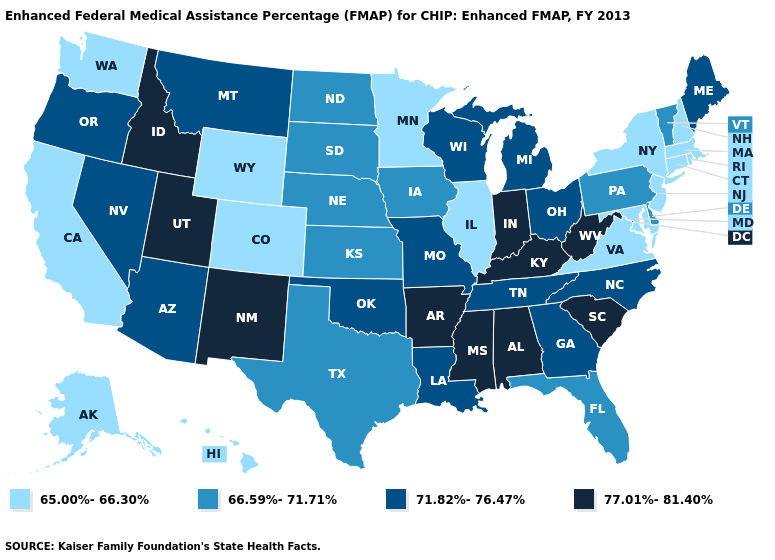What is the value of Massachusetts?
Quick response, please. 65.00%-66.30%. Does Alaska have the highest value in the USA?
Quick response, please. No. Name the states that have a value in the range 71.82%-76.47%?
Short answer required. Arizona, Georgia, Louisiana, Maine, Michigan, Missouri, Montana, Nevada, North Carolina, Ohio, Oklahoma, Oregon, Tennessee, Wisconsin. What is the value of New Jersey?
Be succinct. 65.00%-66.30%. Name the states that have a value in the range 65.00%-66.30%?
Keep it brief. Alaska, California, Colorado, Connecticut, Hawaii, Illinois, Maryland, Massachusetts, Minnesota, New Hampshire, New Jersey, New York, Rhode Island, Virginia, Washington, Wyoming. Which states have the lowest value in the MidWest?
Keep it brief. Illinois, Minnesota. Name the states that have a value in the range 66.59%-71.71%?
Concise answer only. Delaware, Florida, Iowa, Kansas, Nebraska, North Dakota, Pennsylvania, South Dakota, Texas, Vermont. What is the value of Vermont?
Give a very brief answer. 66.59%-71.71%. Name the states that have a value in the range 66.59%-71.71%?
Be succinct. Delaware, Florida, Iowa, Kansas, Nebraska, North Dakota, Pennsylvania, South Dakota, Texas, Vermont. What is the lowest value in the USA?
Quick response, please. 65.00%-66.30%. Which states have the highest value in the USA?
Give a very brief answer. Alabama, Arkansas, Idaho, Indiana, Kentucky, Mississippi, New Mexico, South Carolina, Utah, West Virginia. Does Maine have the same value as North Carolina?
Keep it brief. Yes. Name the states that have a value in the range 71.82%-76.47%?
Give a very brief answer. Arizona, Georgia, Louisiana, Maine, Michigan, Missouri, Montana, Nevada, North Carolina, Ohio, Oklahoma, Oregon, Tennessee, Wisconsin. Among the states that border North Carolina , does Tennessee have the lowest value?
Quick response, please. No. Among the states that border Illinois , does Wisconsin have the highest value?
Give a very brief answer. No. 